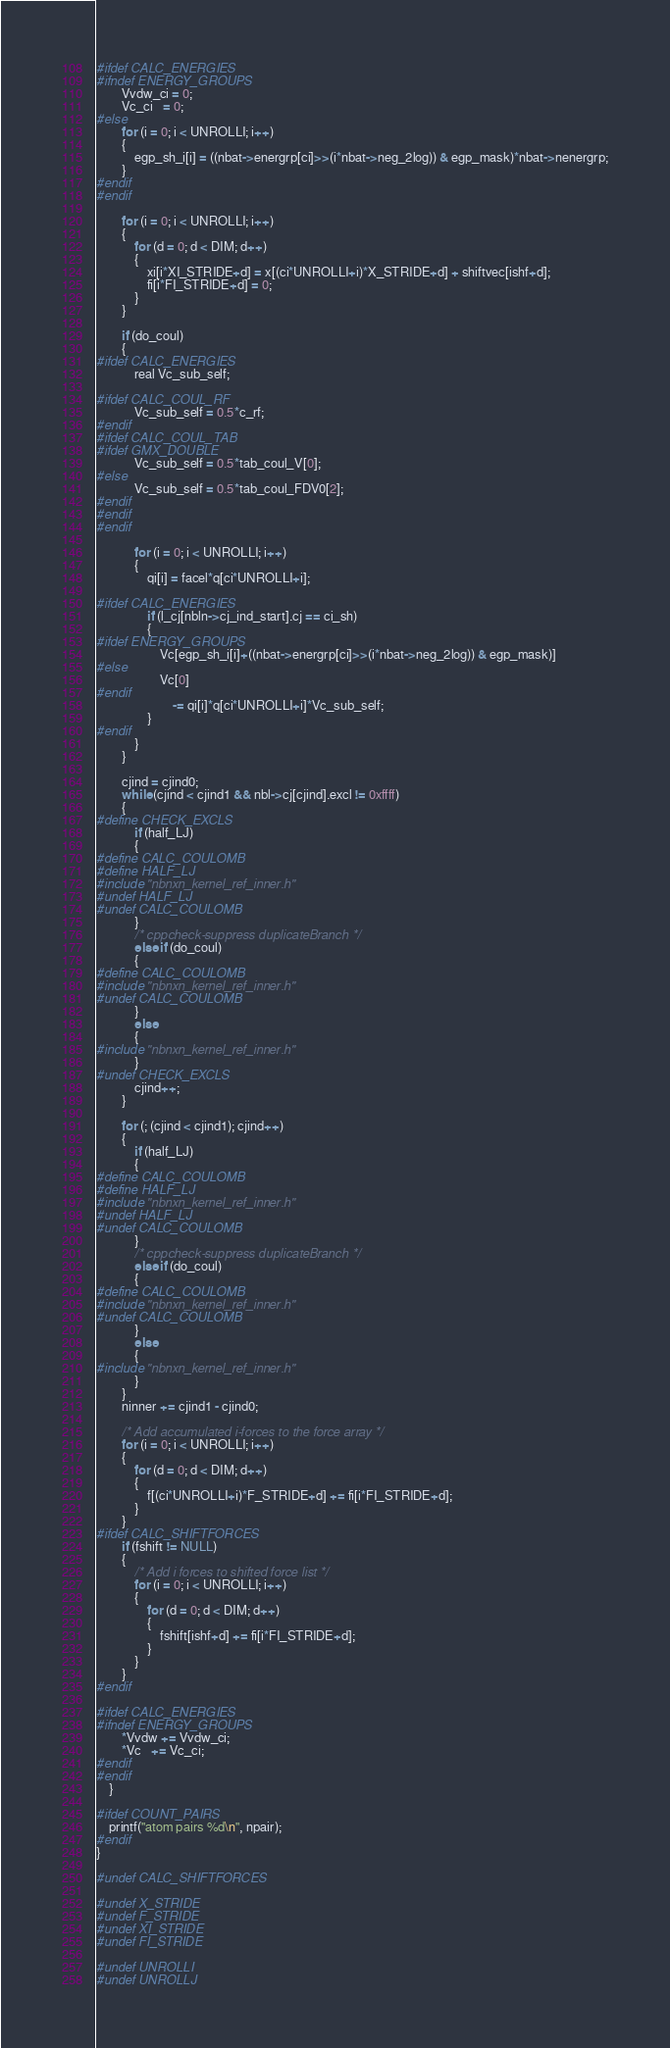Convert code to text. <code><loc_0><loc_0><loc_500><loc_500><_C_>
#ifdef CALC_ENERGIES
#ifndef ENERGY_GROUPS
        Vvdw_ci = 0;
        Vc_ci   = 0;
#else
        for (i = 0; i < UNROLLI; i++)
        {
            egp_sh_i[i] = ((nbat->energrp[ci]>>(i*nbat->neg_2log)) & egp_mask)*nbat->nenergrp;
        }
#endif
#endif

        for (i = 0; i < UNROLLI; i++)
        {
            for (d = 0; d < DIM; d++)
            {
                xi[i*XI_STRIDE+d] = x[(ci*UNROLLI+i)*X_STRIDE+d] + shiftvec[ishf+d];
                fi[i*FI_STRIDE+d] = 0;
            }
        }

        if (do_coul)
        {
#ifdef CALC_ENERGIES
            real Vc_sub_self;

#ifdef CALC_COUL_RF
            Vc_sub_self = 0.5*c_rf;
#endif
#ifdef CALC_COUL_TAB
#ifdef GMX_DOUBLE
            Vc_sub_self = 0.5*tab_coul_V[0];
#else
            Vc_sub_self = 0.5*tab_coul_FDV0[2];
#endif
#endif
#endif

            for (i = 0; i < UNROLLI; i++)
            {
                qi[i] = facel*q[ci*UNROLLI+i];

#ifdef CALC_ENERGIES
                if (l_cj[nbln->cj_ind_start].cj == ci_sh)
                {
#ifdef ENERGY_GROUPS
                    Vc[egp_sh_i[i]+((nbat->energrp[ci]>>(i*nbat->neg_2log)) & egp_mask)]
#else
                    Vc[0]
#endif
                        -= qi[i]*q[ci*UNROLLI+i]*Vc_sub_self;
                }
#endif
            }
        }

        cjind = cjind0;
        while (cjind < cjind1 && nbl->cj[cjind].excl != 0xffff)
        {
#define CHECK_EXCLS
            if (half_LJ)
            {
#define CALC_COULOMB
#define HALF_LJ
#include "nbnxn_kernel_ref_inner.h"
#undef HALF_LJ
#undef CALC_COULOMB
            }
            /* cppcheck-suppress duplicateBranch */
            else if (do_coul)
            {
#define CALC_COULOMB
#include "nbnxn_kernel_ref_inner.h"
#undef CALC_COULOMB
            }
            else
            {
#include "nbnxn_kernel_ref_inner.h"
            }
#undef CHECK_EXCLS
            cjind++;
        }

        for (; (cjind < cjind1); cjind++)
        {
            if (half_LJ)
            {
#define CALC_COULOMB
#define HALF_LJ
#include "nbnxn_kernel_ref_inner.h"
#undef HALF_LJ
#undef CALC_COULOMB
            }
            /* cppcheck-suppress duplicateBranch */
            else if (do_coul)
            {
#define CALC_COULOMB
#include "nbnxn_kernel_ref_inner.h"
#undef CALC_COULOMB
            }
            else
            {
#include "nbnxn_kernel_ref_inner.h"
            }
        }
        ninner += cjind1 - cjind0;

        /* Add accumulated i-forces to the force array */
        for (i = 0; i < UNROLLI; i++)
        {
            for (d = 0; d < DIM; d++)
            {
                f[(ci*UNROLLI+i)*F_STRIDE+d] += fi[i*FI_STRIDE+d];
            }
        }
#ifdef CALC_SHIFTFORCES
        if (fshift != NULL)
        {
            /* Add i forces to shifted force list */
            for (i = 0; i < UNROLLI; i++)
            {
                for (d = 0; d < DIM; d++)
                {
                    fshift[ishf+d] += fi[i*FI_STRIDE+d];
                }
            }
        }
#endif

#ifdef CALC_ENERGIES
#ifndef ENERGY_GROUPS
        *Vvdw += Vvdw_ci;
        *Vc   += Vc_ci;
#endif
#endif
    }

#ifdef COUNT_PAIRS
    printf("atom pairs %d\n", npair);
#endif
}

#undef CALC_SHIFTFORCES

#undef X_STRIDE
#undef F_STRIDE
#undef XI_STRIDE
#undef FI_STRIDE

#undef UNROLLI
#undef UNROLLJ
</code> 